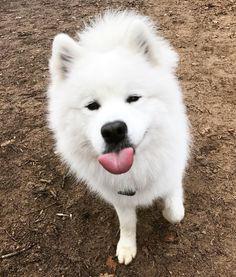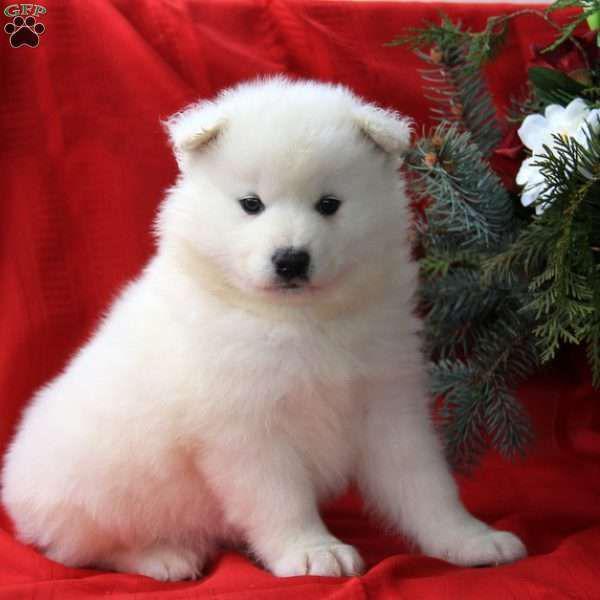The first image is the image on the left, the second image is the image on the right. Analyze the images presented: Is the assertion "In the image to the right, all dogs present are adult;they are mature." valid? Answer yes or no. No. 